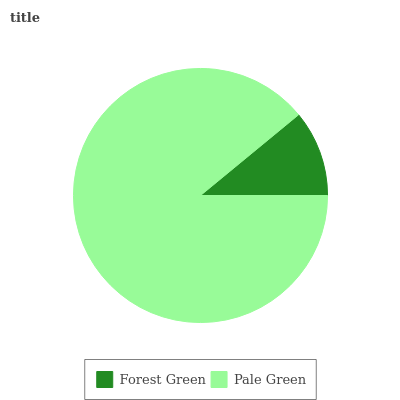Is Forest Green the minimum?
Answer yes or no. Yes. Is Pale Green the maximum?
Answer yes or no. Yes. Is Pale Green the minimum?
Answer yes or no. No. Is Pale Green greater than Forest Green?
Answer yes or no. Yes. Is Forest Green less than Pale Green?
Answer yes or no. Yes. Is Forest Green greater than Pale Green?
Answer yes or no. No. Is Pale Green less than Forest Green?
Answer yes or no. No. Is Pale Green the high median?
Answer yes or no. Yes. Is Forest Green the low median?
Answer yes or no. Yes. Is Forest Green the high median?
Answer yes or no. No. Is Pale Green the low median?
Answer yes or no. No. 